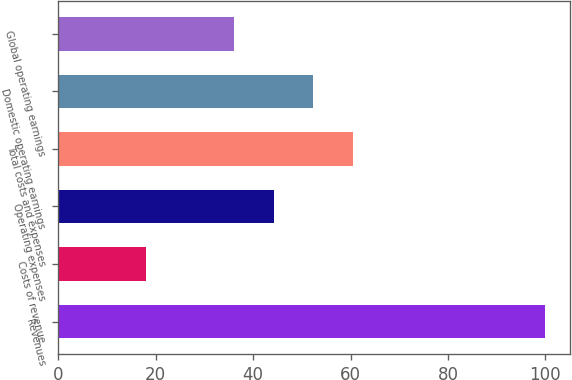Convert chart. <chart><loc_0><loc_0><loc_500><loc_500><bar_chart><fcel>Revenues<fcel>Costs of revenue<fcel>Operating expenses<fcel>Total costs and expenses<fcel>Domestic operating earnings<fcel>Global operating earnings<nl><fcel>100<fcel>18<fcel>44.2<fcel>60.6<fcel>52.4<fcel>36<nl></chart> 